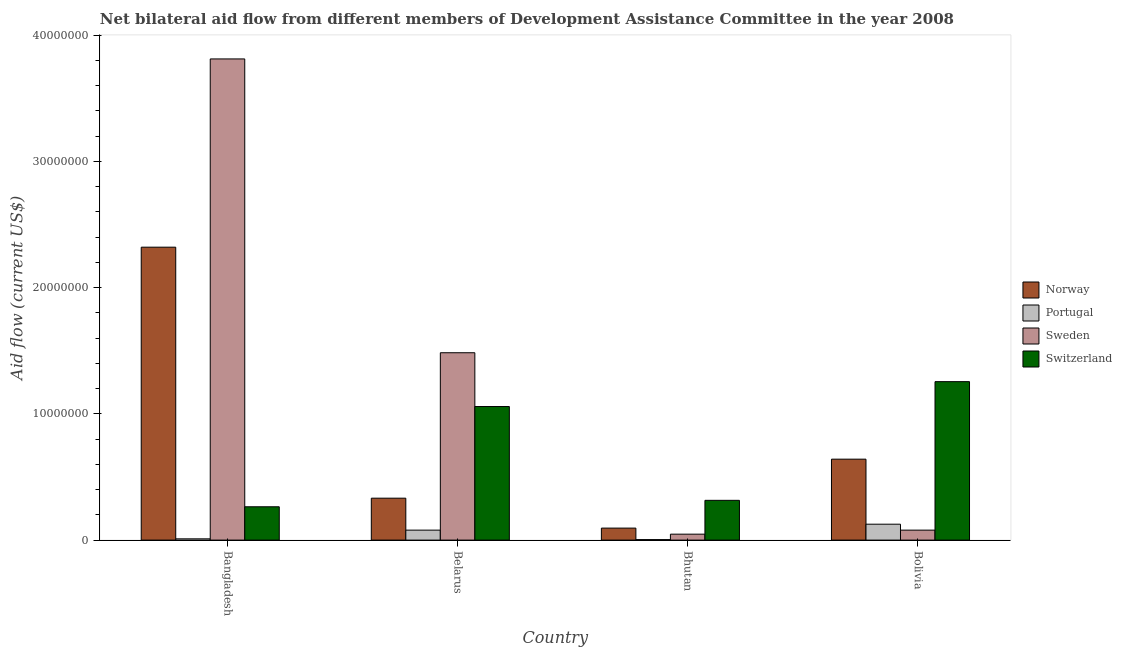How many groups of bars are there?
Give a very brief answer. 4. How many bars are there on the 4th tick from the left?
Your answer should be compact. 4. What is the label of the 2nd group of bars from the left?
Your answer should be compact. Belarus. What is the amount of aid given by norway in Bhutan?
Your response must be concise. 9.50e+05. Across all countries, what is the maximum amount of aid given by sweden?
Offer a terse response. 3.81e+07. Across all countries, what is the minimum amount of aid given by sweden?
Your answer should be compact. 4.70e+05. In which country was the amount of aid given by switzerland minimum?
Provide a short and direct response. Bangladesh. What is the total amount of aid given by norway in the graph?
Ensure brevity in your answer.  3.39e+07. What is the difference between the amount of aid given by sweden in Bhutan and that in Bolivia?
Your answer should be very brief. -3.20e+05. What is the difference between the amount of aid given by portugal in Bangladesh and the amount of aid given by switzerland in Bhutan?
Provide a succinct answer. -3.05e+06. What is the average amount of aid given by portugal per country?
Give a very brief answer. 5.48e+05. What is the difference between the amount of aid given by sweden and amount of aid given by switzerland in Belarus?
Provide a short and direct response. 4.26e+06. What is the ratio of the amount of aid given by portugal in Bangladesh to that in Bolivia?
Provide a succinct answer. 0.08. Is the difference between the amount of aid given by norway in Bangladesh and Belarus greater than the difference between the amount of aid given by switzerland in Bangladesh and Belarus?
Provide a short and direct response. Yes. What is the difference between the highest and the second highest amount of aid given by sweden?
Your answer should be very brief. 2.33e+07. What is the difference between the highest and the lowest amount of aid given by sweden?
Provide a short and direct response. 3.76e+07. In how many countries, is the amount of aid given by switzerland greater than the average amount of aid given by switzerland taken over all countries?
Give a very brief answer. 2. Is the sum of the amount of aid given by sweden in Belarus and Bhutan greater than the maximum amount of aid given by portugal across all countries?
Make the answer very short. Yes. Is it the case that in every country, the sum of the amount of aid given by portugal and amount of aid given by norway is greater than the sum of amount of aid given by switzerland and amount of aid given by sweden?
Offer a terse response. No. What does the 4th bar from the left in Bhutan represents?
Provide a succinct answer. Switzerland. What does the 1st bar from the right in Bangladesh represents?
Make the answer very short. Switzerland. Is it the case that in every country, the sum of the amount of aid given by norway and amount of aid given by portugal is greater than the amount of aid given by sweden?
Offer a terse response. No. How many bars are there?
Your response must be concise. 16. How many countries are there in the graph?
Provide a succinct answer. 4. What is the difference between two consecutive major ticks on the Y-axis?
Your answer should be very brief. 1.00e+07. How are the legend labels stacked?
Keep it short and to the point. Vertical. What is the title of the graph?
Your answer should be very brief. Net bilateral aid flow from different members of Development Assistance Committee in the year 2008. What is the label or title of the Y-axis?
Provide a succinct answer. Aid flow (current US$). What is the Aid flow (current US$) in Norway in Bangladesh?
Offer a terse response. 2.32e+07. What is the Aid flow (current US$) in Portugal in Bangladesh?
Make the answer very short. 1.00e+05. What is the Aid flow (current US$) in Sweden in Bangladesh?
Provide a short and direct response. 3.81e+07. What is the Aid flow (current US$) in Switzerland in Bangladesh?
Offer a very short reply. 2.64e+06. What is the Aid flow (current US$) of Norway in Belarus?
Provide a succinct answer. 3.32e+06. What is the Aid flow (current US$) in Portugal in Belarus?
Offer a terse response. 7.90e+05. What is the Aid flow (current US$) in Sweden in Belarus?
Give a very brief answer. 1.48e+07. What is the Aid flow (current US$) in Switzerland in Belarus?
Your answer should be very brief. 1.06e+07. What is the Aid flow (current US$) in Norway in Bhutan?
Your response must be concise. 9.50e+05. What is the Aid flow (current US$) in Switzerland in Bhutan?
Provide a succinct answer. 3.15e+06. What is the Aid flow (current US$) in Norway in Bolivia?
Provide a short and direct response. 6.41e+06. What is the Aid flow (current US$) in Portugal in Bolivia?
Make the answer very short. 1.26e+06. What is the Aid flow (current US$) of Sweden in Bolivia?
Your answer should be compact. 7.90e+05. What is the Aid flow (current US$) in Switzerland in Bolivia?
Your response must be concise. 1.26e+07. Across all countries, what is the maximum Aid flow (current US$) of Norway?
Offer a terse response. 2.32e+07. Across all countries, what is the maximum Aid flow (current US$) of Portugal?
Give a very brief answer. 1.26e+06. Across all countries, what is the maximum Aid flow (current US$) of Sweden?
Keep it short and to the point. 3.81e+07. Across all countries, what is the maximum Aid flow (current US$) in Switzerland?
Ensure brevity in your answer.  1.26e+07. Across all countries, what is the minimum Aid flow (current US$) in Norway?
Your response must be concise. 9.50e+05. Across all countries, what is the minimum Aid flow (current US$) of Sweden?
Make the answer very short. 4.70e+05. Across all countries, what is the minimum Aid flow (current US$) in Switzerland?
Your response must be concise. 2.64e+06. What is the total Aid flow (current US$) in Norway in the graph?
Ensure brevity in your answer.  3.39e+07. What is the total Aid flow (current US$) in Portugal in the graph?
Your answer should be very brief. 2.19e+06. What is the total Aid flow (current US$) of Sweden in the graph?
Your answer should be compact. 5.42e+07. What is the total Aid flow (current US$) in Switzerland in the graph?
Give a very brief answer. 2.89e+07. What is the difference between the Aid flow (current US$) of Norway in Bangladesh and that in Belarus?
Offer a terse response. 1.99e+07. What is the difference between the Aid flow (current US$) in Portugal in Bangladesh and that in Belarus?
Offer a terse response. -6.90e+05. What is the difference between the Aid flow (current US$) in Sweden in Bangladesh and that in Belarus?
Keep it short and to the point. 2.33e+07. What is the difference between the Aid flow (current US$) of Switzerland in Bangladesh and that in Belarus?
Your answer should be compact. -7.94e+06. What is the difference between the Aid flow (current US$) of Norway in Bangladesh and that in Bhutan?
Give a very brief answer. 2.22e+07. What is the difference between the Aid flow (current US$) in Portugal in Bangladesh and that in Bhutan?
Provide a short and direct response. 6.00e+04. What is the difference between the Aid flow (current US$) in Sweden in Bangladesh and that in Bhutan?
Your answer should be compact. 3.76e+07. What is the difference between the Aid flow (current US$) of Switzerland in Bangladesh and that in Bhutan?
Provide a succinct answer. -5.10e+05. What is the difference between the Aid flow (current US$) of Norway in Bangladesh and that in Bolivia?
Provide a short and direct response. 1.68e+07. What is the difference between the Aid flow (current US$) of Portugal in Bangladesh and that in Bolivia?
Keep it short and to the point. -1.16e+06. What is the difference between the Aid flow (current US$) of Sweden in Bangladesh and that in Bolivia?
Make the answer very short. 3.73e+07. What is the difference between the Aid flow (current US$) in Switzerland in Bangladesh and that in Bolivia?
Provide a short and direct response. -9.91e+06. What is the difference between the Aid flow (current US$) in Norway in Belarus and that in Bhutan?
Make the answer very short. 2.37e+06. What is the difference between the Aid flow (current US$) of Portugal in Belarus and that in Bhutan?
Your answer should be compact. 7.50e+05. What is the difference between the Aid flow (current US$) in Sweden in Belarus and that in Bhutan?
Your response must be concise. 1.44e+07. What is the difference between the Aid flow (current US$) of Switzerland in Belarus and that in Bhutan?
Keep it short and to the point. 7.43e+06. What is the difference between the Aid flow (current US$) in Norway in Belarus and that in Bolivia?
Your answer should be very brief. -3.09e+06. What is the difference between the Aid flow (current US$) in Portugal in Belarus and that in Bolivia?
Your answer should be very brief. -4.70e+05. What is the difference between the Aid flow (current US$) in Sweden in Belarus and that in Bolivia?
Ensure brevity in your answer.  1.40e+07. What is the difference between the Aid flow (current US$) of Switzerland in Belarus and that in Bolivia?
Your response must be concise. -1.97e+06. What is the difference between the Aid flow (current US$) in Norway in Bhutan and that in Bolivia?
Offer a very short reply. -5.46e+06. What is the difference between the Aid flow (current US$) of Portugal in Bhutan and that in Bolivia?
Offer a very short reply. -1.22e+06. What is the difference between the Aid flow (current US$) in Sweden in Bhutan and that in Bolivia?
Offer a very short reply. -3.20e+05. What is the difference between the Aid flow (current US$) of Switzerland in Bhutan and that in Bolivia?
Provide a succinct answer. -9.40e+06. What is the difference between the Aid flow (current US$) in Norway in Bangladesh and the Aid flow (current US$) in Portugal in Belarus?
Provide a succinct answer. 2.24e+07. What is the difference between the Aid flow (current US$) in Norway in Bangladesh and the Aid flow (current US$) in Sweden in Belarus?
Keep it short and to the point. 8.36e+06. What is the difference between the Aid flow (current US$) in Norway in Bangladesh and the Aid flow (current US$) in Switzerland in Belarus?
Offer a terse response. 1.26e+07. What is the difference between the Aid flow (current US$) of Portugal in Bangladesh and the Aid flow (current US$) of Sweden in Belarus?
Provide a succinct answer. -1.47e+07. What is the difference between the Aid flow (current US$) of Portugal in Bangladesh and the Aid flow (current US$) of Switzerland in Belarus?
Ensure brevity in your answer.  -1.05e+07. What is the difference between the Aid flow (current US$) in Sweden in Bangladesh and the Aid flow (current US$) in Switzerland in Belarus?
Make the answer very short. 2.75e+07. What is the difference between the Aid flow (current US$) in Norway in Bangladesh and the Aid flow (current US$) in Portugal in Bhutan?
Make the answer very short. 2.32e+07. What is the difference between the Aid flow (current US$) of Norway in Bangladesh and the Aid flow (current US$) of Sweden in Bhutan?
Make the answer very short. 2.27e+07. What is the difference between the Aid flow (current US$) of Norway in Bangladesh and the Aid flow (current US$) of Switzerland in Bhutan?
Provide a succinct answer. 2.00e+07. What is the difference between the Aid flow (current US$) in Portugal in Bangladesh and the Aid flow (current US$) in Sweden in Bhutan?
Your answer should be compact. -3.70e+05. What is the difference between the Aid flow (current US$) of Portugal in Bangladesh and the Aid flow (current US$) of Switzerland in Bhutan?
Make the answer very short. -3.05e+06. What is the difference between the Aid flow (current US$) of Sweden in Bangladesh and the Aid flow (current US$) of Switzerland in Bhutan?
Provide a short and direct response. 3.50e+07. What is the difference between the Aid flow (current US$) of Norway in Bangladesh and the Aid flow (current US$) of Portugal in Bolivia?
Your response must be concise. 2.19e+07. What is the difference between the Aid flow (current US$) in Norway in Bangladesh and the Aid flow (current US$) in Sweden in Bolivia?
Ensure brevity in your answer.  2.24e+07. What is the difference between the Aid flow (current US$) in Norway in Bangladesh and the Aid flow (current US$) in Switzerland in Bolivia?
Your response must be concise. 1.06e+07. What is the difference between the Aid flow (current US$) of Portugal in Bangladesh and the Aid flow (current US$) of Sweden in Bolivia?
Give a very brief answer. -6.90e+05. What is the difference between the Aid flow (current US$) of Portugal in Bangladesh and the Aid flow (current US$) of Switzerland in Bolivia?
Your answer should be very brief. -1.24e+07. What is the difference between the Aid flow (current US$) in Sweden in Bangladesh and the Aid flow (current US$) in Switzerland in Bolivia?
Offer a very short reply. 2.56e+07. What is the difference between the Aid flow (current US$) in Norway in Belarus and the Aid flow (current US$) in Portugal in Bhutan?
Ensure brevity in your answer.  3.28e+06. What is the difference between the Aid flow (current US$) in Norway in Belarus and the Aid flow (current US$) in Sweden in Bhutan?
Offer a very short reply. 2.85e+06. What is the difference between the Aid flow (current US$) of Portugal in Belarus and the Aid flow (current US$) of Switzerland in Bhutan?
Offer a very short reply. -2.36e+06. What is the difference between the Aid flow (current US$) in Sweden in Belarus and the Aid flow (current US$) in Switzerland in Bhutan?
Keep it short and to the point. 1.17e+07. What is the difference between the Aid flow (current US$) in Norway in Belarus and the Aid flow (current US$) in Portugal in Bolivia?
Offer a very short reply. 2.06e+06. What is the difference between the Aid flow (current US$) of Norway in Belarus and the Aid flow (current US$) of Sweden in Bolivia?
Your answer should be compact. 2.53e+06. What is the difference between the Aid flow (current US$) of Norway in Belarus and the Aid flow (current US$) of Switzerland in Bolivia?
Your answer should be compact. -9.23e+06. What is the difference between the Aid flow (current US$) in Portugal in Belarus and the Aid flow (current US$) in Sweden in Bolivia?
Your answer should be compact. 0. What is the difference between the Aid flow (current US$) of Portugal in Belarus and the Aid flow (current US$) of Switzerland in Bolivia?
Give a very brief answer. -1.18e+07. What is the difference between the Aid flow (current US$) of Sweden in Belarus and the Aid flow (current US$) of Switzerland in Bolivia?
Provide a short and direct response. 2.29e+06. What is the difference between the Aid flow (current US$) of Norway in Bhutan and the Aid flow (current US$) of Portugal in Bolivia?
Your answer should be very brief. -3.10e+05. What is the difference between the Aid flow (current US$) of Norway in Bhutan and the Aid flow (current US$) of Switzerland in Bolivia?
Your answer should be very brief. -1.16e+07. What is the difference between the Aid flow (current US$) in Portugal in Bhutan and the Aid flow (current US$) in Sweden in Bolivia?
Offer a very short reply. -7.50e+05. What is the difference between the Aid flow (current US$) of Portugal in Bhutan and the Aid flow (current US$) of Switzerland in Bolivia?
Provide a short and direct response. -1.25e+07. What is the difference between the Aid flow (current US$) in Sweden in Bhutan and the Aid flow (current US$) in Switzerland in Bolivia?
Ensure brevity in your answer.  -1.21e+07. What is the average Aid flow (current US$) of Norway per country?
Your answer should be very brief. 8.47e+06. What is the average Aid flow (current US$) of Portugal per country?
Offer a terse response. 5.48e+05. What is the average Aid flow (current US$) in Sweden per country?
Make the answer very short. 1.36e+07. What is the average Aid flow (current US$) of Switzerland per country?
Provide a short and direct response. 7.23e+06. What is the difference between the Aid flow (current US$) of Norway and Aid flow (current US$) of Portugal in Bangladesh?
Your answer should be very brief. 2.31e+07. What is the difference between the Aid flow (current US$) in Norway and Aid flow (current US$) in Sweden in Bangladesh?
Keep it short and to the point. -1.49e+07. What is the difference between the Aid flow (current US$) of Norway and Aid flow (current US$) of Switzerland in Bangladesh?
Your response must be concise. 2.06e+07. What is the difference between the Aid flow (current US$) of Portugal and Aid flow (current US$) of Sweden in Bangladesh?
Your answer should be compact. -3.80e+07. What is the difference between the Aid flow (current US$) of Portugal and Aid flow (current US$) of Switzerland in Bangladesh?
Ensure brevity in your answer.  -2.54e+06. What is the difference between the Aid flow (current US$) in Sweden and Aid flow (current US$) in Switzerland in Bangladesh?
Make the answer very short. 3.55e+07. What is the difference between the Aid flow (current US$) in Norway and Aid flow (current US$) in Portugal in Belarus?
Offer a very short reply. 2.53e+06. What is the difference between the Aid flow (current US$) of Norway and Aid flow (current US$) of Sweden in Belarus?
Provide a short and direct response. -1.15e+07. What is the difference between the Aid flow (current US$) of Norway and Aid flow (current US$) of Switzerland in Belarus?
Ensure brevity in your answer.  -7.26e+06. What is the difference between the Aid flow (current US$) of Portugal and Aid flow (current US$) of Sweden in Belarus?
Your answer should be very brief. -1.40e+07. What is the difference between the Aid flow (current US$) in Portugal and Aid flow (current US$) in Switzerland in Belarus?
Offer a terse response. -9.79e+06. What is the difference between the Aid flow (current US$) in Sweden and Aid flow (current US$) in Switzerland in Belarus?
Your answer should be compact. 4.26e+06. What is the difference between the Aid flow (current US$) of Norway and Aid flow (current US$) of Portugal in Bhutan?
Offer a terse response. 9.10e+05. What is the difference between the Aid flow (current US$) in Norway and Aid flow (current US$) in Switzerland in Bhutan?
Your response must be concise. -2.20e+06. What is the difference between the Aid flow (current US$) of Portugal and Aid flow (current US$) of Sweden in Bhutan?
Your answer should be very brief. -4.30e+05. What is the difference between the Aid flow (current US$) of Portugal and Aid flow (current US$) of Switzerland in Bhutan?
Provide a succinct answer. -3.11e+06. What is the difference between the Aid flow (current US$) in Sweden and Aid flow (current US$) in Switzerland in Bhutan?
Provide a succinct answer. -2.68e+06. What is the difference between the Aid flow (current US$) in Norway and Aid flow (current US$) in Portugal in Bolivia?
Offer a very short reply. 5.15e+06. What is the difference between the Aid flow (current US$) of Norway and Aid flow (current US$) of Sweden in Bolivia?
Ensure brevity in your answer.  5.62e+06. What is the difference between the Aid flow (current US$) of Norway and Aid flow (current US$) of Switzerland in Bolivia?
Your answer should be very brief. -6.14e+06. What is the difference between the Aid flow (current US$) of Portugal and Aid flow (current US$) of Sweden in Bolivia?
Your response must be concise. 4.70e+05. What is the difference between the Aid flow (current US$) of Portugal and Aid flow (current US$) of Switzerland in Bolivia?
Give a very brief answer. -1.13e+07. What is the difference between the Aid flow (current US$) in Sweden and Aid flow (current US$) in Switzerland in Bolivia?
Ensure brevity in your answer.  -1.18e+07. What is the ratio of the Aid flow (current US$) in Norway in Bangladesh to that in Belarus?
Provide a short and direct response. 6.99. What is the ratio of the Aid flow (current US$) in Portugal in Bangladesh to that in Belarus?
Provide a short and direct response. 0.13. What is the ratio of the Aid flow (current US$) in Sweden in Bangladesh to that in Belarus?
Keep it short and to the point. 2.57. What is the ratio of the Aid flow (current US$) in Switzerland in Bangladesh to that in Belarus?
Your answer should be compact. 0.25. What is the ratio of the Aid flow (current US$) in Norway in Bangladesh to that in Bhutan?
Ensure brevity in your answer.  24.42. What is the ratio of the Aid flow (current US$) of Portugal in Bangladesh to that in Bhutan?
Keep it short and to the point. 2.5. What is the ratio of the Aid flow (current US$) of Sweden in Bangladesh to that in Bhutan?
Provide a short and direct response. 81.09. What is the ratio of the Aid flow (current US$) in Switzerland in Bangladesh to that in Bhutan?
Give a very brief answer. 0.84. What is the ratio of the Aid flow (current US$) in Norway in Bangladesh to that in Bolivia?
Ensure brevity in your answer.  3.62. What is the ratio of the Aid flow (current US$) in Portugal in Bangladesh to that in Bolivia?
Offer a very short reply. 0.08. What is the ratio of the Aid flow (current US$) of Sweden in Bangladesh to that in Bolivia?
Make the answer very short. 48.24. What is the ratio of the Aid flow (current US$) in Switzerland in Bangladesh to that in Bolivia?
Give a very brief answer. 0.21. What is the ratio of the Aid flow (current US$) in Norway in Belarus to that in Bhutan?
Your response must be concise. 3.49. What is the ratio of the Aid flow (current US$) of Portugal in Belarus to that in Bhutan?
Provide a succinct answer. 19.75. What is the ratio of the Aid flow (current US$) in Sweden in Belarus to that in Bhutan?
Your response must be concise. 31.57. What is the ratio of the Aid flow (current US$) in Switzerland in Belarus to that in Bhutan?
Make the answer very short. 3.36. What is the ratio of the Aid flow (current US$) of Norway in Belarus to that in Bolivia?
Give a very brief answer. 0.52. What is the ratio of the Aid flow (current US$) in Portugal in Belarus to that in Bolivia?
Provide a short and direct response. 0.63. What is the ratio of the Aid flow (current US$) in Sweden in Belarus to that in Bolivia?
Your response must be concise. 18.78. What is the ratio of the Aid flow (current US$) of Switzerland in Belarus to that in Bolivia?
Make the answer very short. 0.84. What is the ratio of the Aid flow (current US$) in Norway in Bhutan to that in Bolivia?
Offer a terse response. 0.15. What is the ratio of the Aid flow (current US$) of Portugal in Bhutan to that in Bolivia?
Provide a short and direct response. 0.03. What is the ratio of the Aid flow (current US$) in Sweden in Bhutan to that in Bolivia?
Give a very brief answer. 0.59. What is the ratio of the Aid flow (current US$) in Switzerland in Bhutan to that in Bolivia?
Make the answer very short. 0.25. What is the difference between the highest and the second highest Aid flow (current US$) of Norway?
Keep it short and to the point. 1.68e+07. What is the difference between the highest and the second highest Aid flow (current US$) in Portugal?
Provide a succinct answer. 4.70e+05. What is the difference between the highest and the second highest Aid flow (current US$) in Sweden?
Your response must be concise. 2.33e+07. What is the difference between the highest and the second highest Aid flow (current US$) of Switzerland?
Keep it short and to the point. 1.97e+06. What is the difference between the highest and the lowest Aid flow (current US$) of Norway?
Offer a very short reply. 2.22e+07. What is the difference between the highest and the lowest Aid flow (current US$) in Portugal?
Keep it short and to the point. 1.22e+06. What is the difference between the highest and the lowest Aid flow (current US$) of Sweden?
Your answer should be very brief. 3.76e+07. What is the difference between the highest and the lowest Aid flow (current US$) of Switzerland?
Provide a succinct answer. 9.91e+06. 